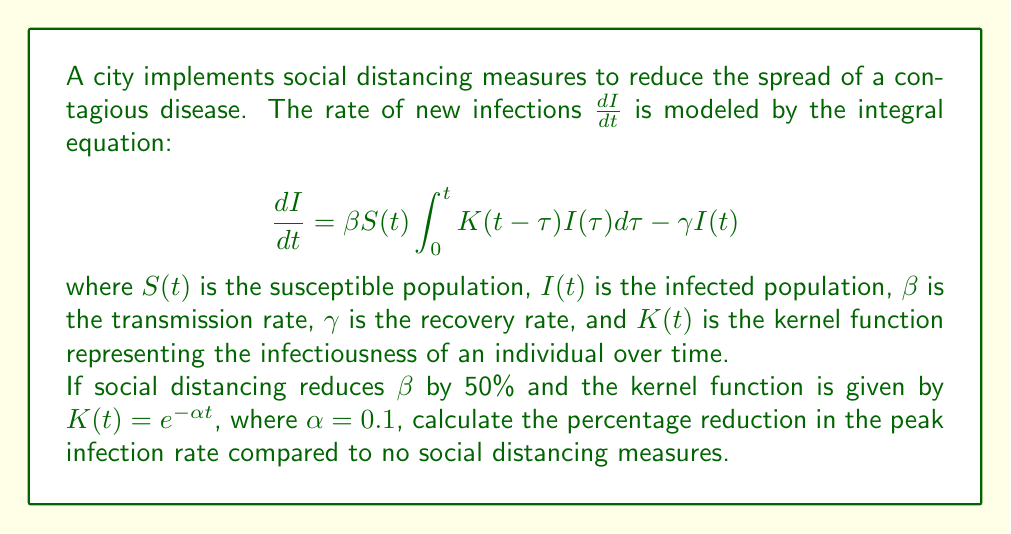Provide a solution to this math problem. To solve this problem, we'll follow these steps:

1) First, we need to understand the components of the model:
   - $\frac{dI}{dt}$ represents the rate of change in infections
   - $\beta S(t)$ represents the rate at which susceptible individuals come into contact with infected individuals
   - $\int_{0}^{t} K(t-\tau)I(\tau)d\tau$ represents the total infectiousness of all currently infected individuals
   - $\gamma I(t)$ represents the rate at which infected individuals recover

2) The peak infection rate occurs when $\frac{dI}{dt}$ is at its maximum. Let's call this maximum value $M$ for the scenario without social distancing.

3) With social distancing, $\beta$ is reduced by 50%, so the new transmission rate is $0.5\beta$. Let's call the new maximum infection rate $M_{SD}$.

4) The ratio of $M_{SD}$ to $M$ will be:

   $$\frac{M_{SD}}{M} = \frac{0.5\beta S(t) \int_{0}^{t} K(t-\tau)I(\tau)d\tau - \gamma I(t)}{\beta S(t) \int_{0}^{t} K(t-\tau)I(\tau)d\tau - \gamma I(t)}$$

5) Simplifying this ratio:

   $$\frac{M_{SD}}{M} = \frac{0.5\beta S(t) \int_{0}^{t} K(t-\tau)I(\tau)d\tau - \gamma I(t)}{\beta S(t) \int_{0}^{t} K(t-\tau)I(\tau)d\tau - \gamma I(t)}$$

   $$= \frac{0.5(\beta S(t) \int_{0}^{t} K(t-\tau)I(\tau)d\tau) - \gamma I(t)}{\beta S(t) \int_{0}^{t} K(t-\tau)I(\tau)d\tau - \gamma I(t)}$$

6) At the peak, $\beta S(t) \int_{0}^{t} K(t-\tau)I(\tau)d\tau$ must be greater than $\gamma I(t)$, otherwise the infection rate would be decreasing. Let's say $\beta S(t) \int_{0}^{t} K(t-\tau)I(\tau)d\tau = x\gamma I(t)$, where $x > 1$.

7) Substituting this into our ratio:

   $$\frac{M_{SD}}{M} = \frac{0.5x\gamma I(t) - \gamma I(t)}{x\gamma I(t) - \gamma I(t)} = \frac{0.5x - 1}{x - 1}$$

8) As $x$ approaches infinity (representing a very high transmission rate compared to recovery rate), this ratio approaches 0.5.

9) Therefore, the maximum reduction in peak infection rate is 50%.

10) The percentage reduction is thus (1 - 0.5) * 100% = 50%.
Answer: 50% 